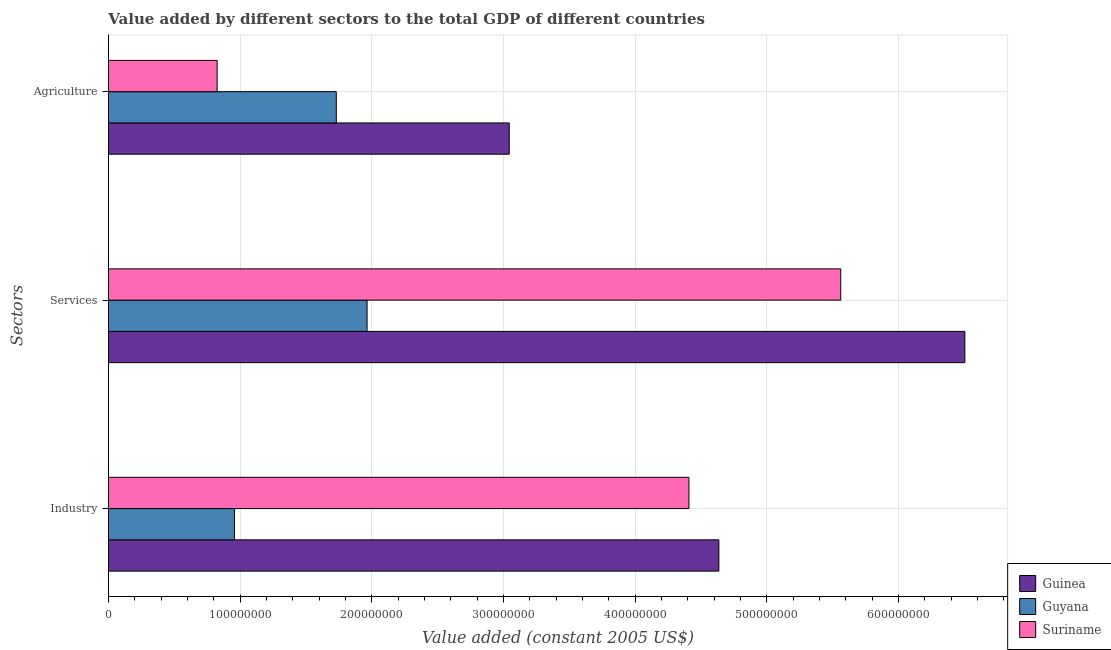How many different coloured bars are there?
Your response must be concise. 3. How many bars are there on the 3rd tick from the top?
Your answer should be very brief. 3. How many bars are there on the 1st tick from the bottom?
Provide a short and direct response. 3. What is the label of the 2nd group of bars from the top?
Your answer should be compact. Services. What is the value added by services in Suriname?
Your answer should be very brief. 5.56e+08. Across all countries, what is the maximum value added by industrial sector?
Make the answer very short. 4.64e+08. Across all countries, what is the minimum value added by industrial sector?
Ensure brevity in your answer.  9.57e+07. In which country was the value added by agricultural sector maximum?
Ensure brevity in your answer.  Guinea. In which country was the value added by industrial sector minimum?
Make the answer very short. Guyana. What is the total value added by agricultural sector in the graph?
Your answer should be very brief. 5.60e+08. What is the difference between the value added by services in Suriname and that in Guyana?
Keep it short and to the point. 3.60e+08. What is the difference between the value added by industrial sector in Suriname and the value added by services in Guinea?
Your response must be concise. -2.09e+08. What is the average value added by agricultural sector per country?
Your answer should be compact. 1.87e+08. What is the difference between the value added by industrial sector and value added by services in Guyana?
Offer a very short reply. -1.01e+08. What is the ratio of the value added by agricultural sector in Guyana to that in Suriname?
Your response must be concise. 2.1. What is the difference between the highest and the second highest value added by industrial sector?
Offer a very short reply. 2.27e+07. What is the difference between the highest and the lowest value added by agricultural sector?
Offer a very short reply. 2.22e+08. What does the 3rd bar from the top in Services represents?
Offer a very short reply. Guinea. What does the 1st bar from the bottom in Agriculture represents?
Offer a very short reply. Guinea. Is it the case that in every country, the sum of the value added by industrial sector and value added by services is greater than the value added by agricultural sector?
Provide a short and direct response. Yes. How many bars are there?
Make the answer very short. 9. Does the graph contain any zero values?
Make the answer very short. No. Does the graph contain grids?
Make the answer very short. Yes. How many legend labels are there?
Give a very brief answer. 3. What is the title of the graph?
Your answer should be compact. Value added by different sectors to the total GDP of different countries. What is the label or title of the X-axis?
Offer a terse response. Value added (constant 2005 US$). What is the label or title of the Y-axis?
Your answer should be compact. Sectors. What is the Value added (constant 2005 US$) of Guinea in Industry?
Your response must be concise. 4.64e+08. What is the Value added (constant 2005 US$) of Guyana in Industry?
Keep it short and to the point. 9.57e+07. What is the Value added (constant 2005 US$) in Suriname in Industry?
Your answer should be compact. 4.41e+08. What is the Value added (constant 2005 US$) in Guinea in Services?
Your answer should be compact. 6.50e+08. What is the Value added (constant 2005 US$) of Guyana in Services?
Your answer should be very brief. 1.96e+08. What is the Value added (constant 2005 US$) of Suriname in Services?
Keep it short and to the point. 5.56e+08. What is the Value added (constant 2005 US$) in Guinea in Agriculture?
Make the answer very short. 3.04e+08. What is the Value added (constant 2005 US$) in Guyana in Agriculture?
Offer a very short reply. 1.73e+08. What is the Value added (constant 2005 US$) of Suriname in Agriculture?
Keep it short and to the point. 8.26e+07. Across all Sectors, what is the maximum Value added (constant 2005 US$) of Guinea?
Make the answer very short. 6.50e+08. Across all Sectors, what is the maximum Value added (constant 2005 US$) of Guyana?
Keep it short and to the point. 1.96e+08. Across all Sectors, what is the maximum Value added (constant 2005 US$) in Suriname?
Offer a terse response. 5.56e+08. Across all Sectors, what is the minimum Value added (constant 2005 US$) of Guinea?
Give a very brief answer. 3.04e+08. Across all Sectors, what is the minimum Value added (constant 2005 US$) in Guyana?
Provide a short and direct response. 9.57e+07. Across all Sectors, what is the minimum Value added (constant 2005 US$) of Suriname?
Your response must be concise. 8.26e+07. What is the total Value added (constant 2005 US$) in Guinea in the graph?
Provide a short and direct response. 1.42e+09. What is the total Value added (constant 2005 US$) in Guyana in the graph?
Offer a very short reply. 4.65e+08. What is the total Value added (constant 2005 US$) of Suriname in the graph?
Provide a succinct answer. 1.08e+09. What is the difference between the Value added (constant 2005 US$) of Guinea in Industry and that in Services?
Provide a succinct answer. -1.87e+08. What is the difference between the Value added (constant 2005 US$) of Guyana in Industry and that in Services?
Provide a short and direct response. -1.01e+08. What is the difference between the Value added (constant 2005 US$) of Suriname in Industry and that in Services?
Your answer should be compact. -1.15e+08. What is the difference between the Value added (constant 2005 US$) of Guinea in Industry and that in Agriculture?
Offer a terse response. 1.59e+08. What is the difference between the Value added (constant 2005 US$) of Guyana in Industry and that in Agriculture?
Make the answer very short. -7.73e+07. What is the difference between the Value added (constant 2005 US$) in Suriname in Industry and that in Agriculture?
Provide a short and direct response. 3.58e+08. What is the difference between the Value added (constant 2005 US$) of Guinea in Services and that in Agriculture?
Keep it short and to the point. 3.46e+08. What is the difference between the Value added (constant 2005 US$) in Guyana in Services and that in Agriculture?
Ensure brevity in your answer.  2.34e+07. What is the difference between the Value added (constant 2005 US$) in Suriname in Services and that in Agriculture?
Offer a terse response. 4.73e+08. What is the difference between the Value added (constant 2005 US$) in Guinea in Industry and the Value added (constant 2005 US$) in Guyana in Services?
Provide a short and direct response. 2.67e+08. What is the difference between the Value added (constant 2005 US$) in Guinea in Industry and the Value added (constant 2005 US$) in Suriname in Services?
Give a very brief answer. -9.25e+07. What is the difference between the Value added (constant 2005 US$) of Guyana in Industry and the Value added (constant 2005 US$) of Suriname in Services?
Keep it short and to the point. -4.60e+08. What is the difference between the Value added (constant 2005 US$) of Guinea in Industry and the Value added (constant 2005 US$) of Guyana in Agriculture?
Your answer should be very brief. 2.90e+08. What is the difference between the Value added (constant 2005 US$) of Guinea in Industry and the Value added (constant 2005 US$) of Suriname in Agriculture?
Make the answer very short. 3.81e+08. What is the difference between the Value added (constant 2005 US$) of Guyana in Industry and the Value added (constant 2005 US$) of Suriname in Agriculture?
Your answer should be compact. 1.32e+07. What is the difference between the Value added (constant 2005 US$) in Guinea in Services and the Value added (constant 2005 US$) in Guyana in Agriculture?
Ensure brevity in your answer.  4.77e+08. What is the difference between the Value added (constant 2005 US$) in Guinea in Services and the Value added (constant 2005 US$) in Suriname in Agriculture?
Ensure brevity in your answer.  5.68e+08. What is the difference between the Value added (constant 2005 US$) in Guyana in Services and the Value added (constant 2005 US$) in Suriname in Agriculture?
Provide a succinct answer. 1.14e+08. What is the average Value added (constant 2005 US$) of Guinea per Sectors?
Offer a terse response. 4.73e+08. What is the average Value added (constant 2005 US$) in Guyana per Sectors?
Your answer should be very brief. 1.55e+08. What is the average Value added (constant 2005 US$) in Suriname per Sectors?
Offer a terse response. 3.60e+08. What is the difference between the Value added (constant 2005 US$) of Guinea and Value added (constant 2005 US$) of Guyana in Industry?
Provide a succinct answer. 3.68e+08. What is the difference between the Value added (constant 2005 US$) of Guinea and Value added (constant 2005 US$) of Suriname in Industry?
Provide a succinct answer. 2.27e+07. What is the difference between the Value added (constant 2005 US$) in Guyana and Value added (constant 2005 US$) in Suriname in Industry?
Make the answer very short. -3.45e+08. What is the difference between the Value added (constant 2005 US$) of Guinea and Value added (constant 2005 US$) of Guyana in Services?
Give a very brief answer. 4.54e+08. What is the difference between the Value added (constant 2005 US$) of Guinea and Value added (constant 2005 US$) of Suriname in Services?
Keep it short and to the point. 9.42e+07. What is the difference between the Value added (constant 2005 US$) in Guyana and Value added (constant 2005 US$) in Suriname in Services?
Make the answer very short. -3.60e+08. What is the difference between the Value added (constant 2005 US$) of Guinea and Value added (constant 2005 US$) of Guyana in Agriculture?
Offer a very short reply. 1.31e+08. What is the difference between the Value added (constant 2005 US$) of Guinea and Value added (constant 2005 US$) of Suriname in Agriculture?
Give a very brief answer. 2.22e+08. What is the difference between the Value added (constant 2005 US$) in Guyana and Value added (constant 2005 US$) in Suriname in Agriculture?
Give a very brief answer. 9.05e+07. What is the ratio of the Value added (constant 2005 US$) in Guinea in Industry to that in Services?
Your answer should be compact. 0.71. What is the ratio of the Value added (constant 2005 US$) of Guyana in Industry to that in Services?
Offer a very short reply. 0.49. What is the ratio of the Value added (constant 2005 US$) of Suriname in Industry to that in Services?
Offer a very short reply. 0.79. What is the ratio of the Value added (constant 2005 US$) in Guinea in Industry to that in Agriculture?
Offer a very short reply. 1.52. What is the ratio of the Value added (constant 2005 US$) of Guyana in Industry to that in Agriculture?
Keep it short and to the point. 0.55. What is the ratio of the Value added (constant 2005 US$) in Suriname in Industry to that in Agriculture?
Offer a terse response. 5.34. What is the ratio of the Value added (constant 2005 US$) of Guinea in Services to that in Agriculture?
Ensure brevity in your answer.  2.14. What is the ratio of the Value added (constant 2005 US$) in Guyana in Services to that in Agriculture?
Make the answer very short. 1.14. What is the ratio of the Value added (constant 2005 US$) in Suriname in Services to that in Agriculture?
Offer a very short reply. 6.74. What is the difference between the highest and the second highest Value added (constant 2005 US$) of Guinea?
Offer a terse response. 1.87e+08. What is the difference between the highest and the second highest Value added (constant 2005 US$) of Guyana?
Offer a terse response. 2.34e+07. What is the difference between the highest and the second highest Value added (constant 2005 US$) of Suriname?
Provide a succinct answer. 1.15e+08. What is the difference between the highest and the lowest Value added (constant 2005 US$) of Guinea?
Your answer should be very brief. 3.46e+08. What is the difference between the highest and the lowest Value added (constant 2005 US$) of Guyana?
Your response must be concise. 1.01e+08. What is the difference between the highest and the lowest Value added (constant 2005 US$) in Suriname?
Offer a very short reply. 4.73e+08. 